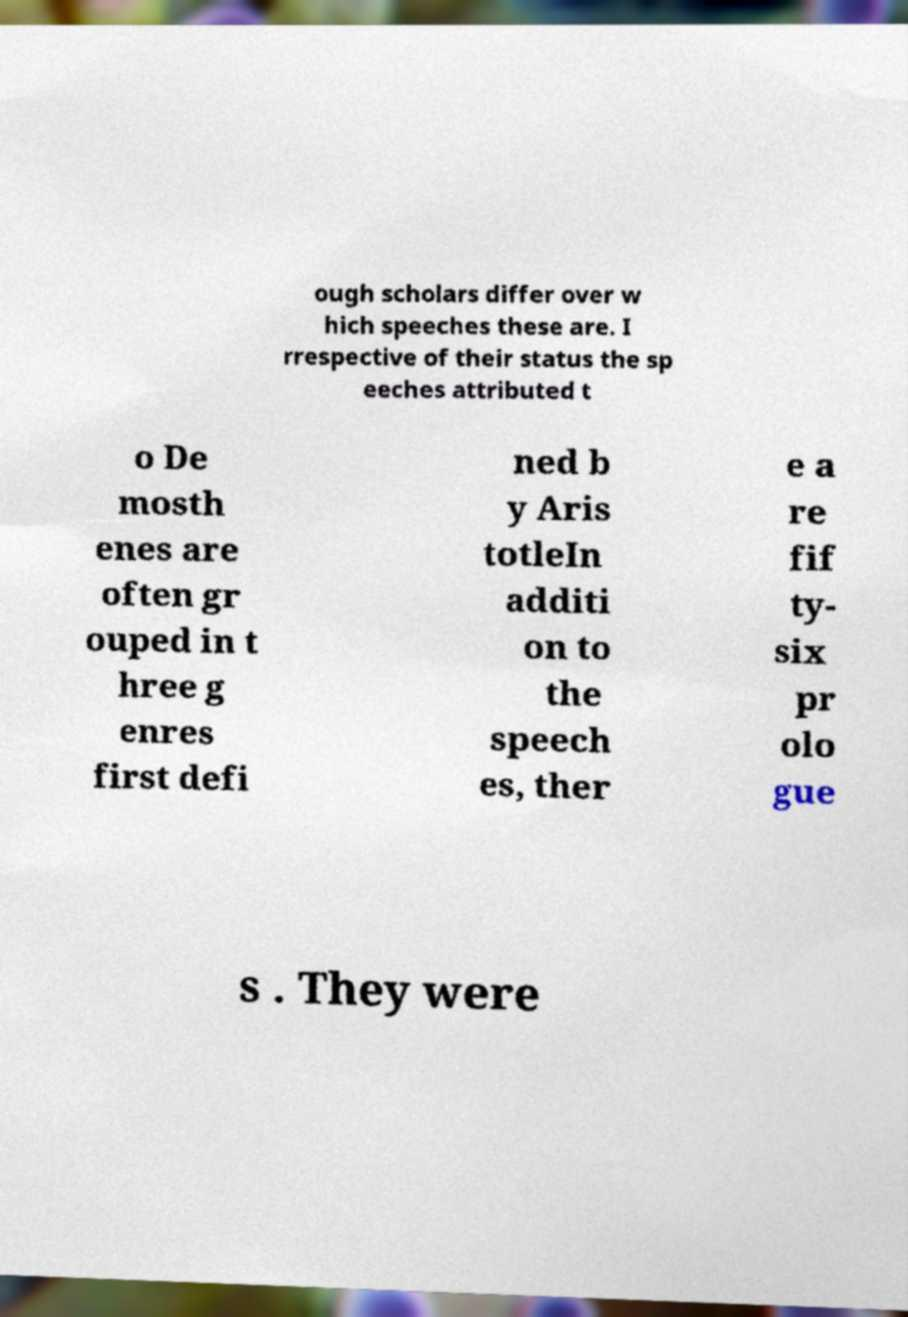For documentation purposes, I need the text within this image transcribed. Could you provide that? ough scholars differ over w hich speeches these are. I rrespective of their status the sp eeches attributed t o De mosth enes are often gr ouped in t hree g enres first defi ned b y Aris totleIn additi on to the speech es, ther e a re fif ty- six pr olo gue s . They were 